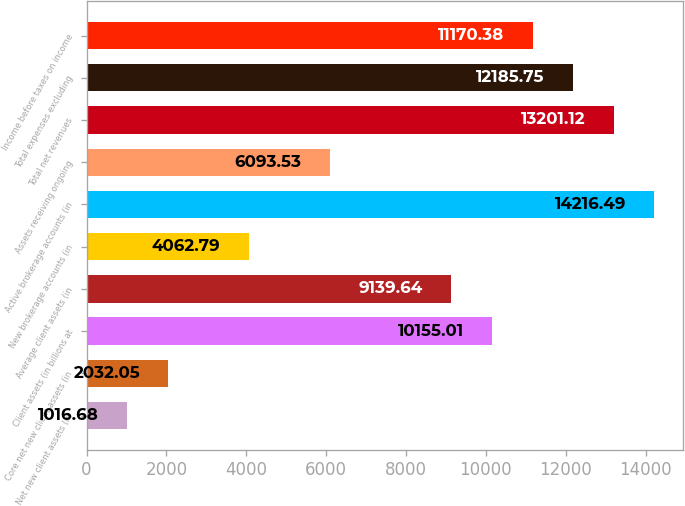<chart> <loc_0><loc_0><loc_500><loc_500><bar_chart><fcel>Net new client assets (in<fcel>Core net new client assets (in<fcel>Client assets (in billions at<fcel>Average client assets (in<fcel>New brokerage accounts (in<fcel>Active brokerage accounts (in<fcel>Assets receiving ongoing<fcel>Total net revenues<fcel>Total expenses excluding<fcel>Income before taxes on income<nl><fcel>1016.68<fcel>2032.05<fcel>10155<fcel>9139.64<fcel>4062.79<fcel>14216.5<fcel>6093.53<fcel>13201.1<fcel>12185.8<fcel>11170.4<nl></chart> 